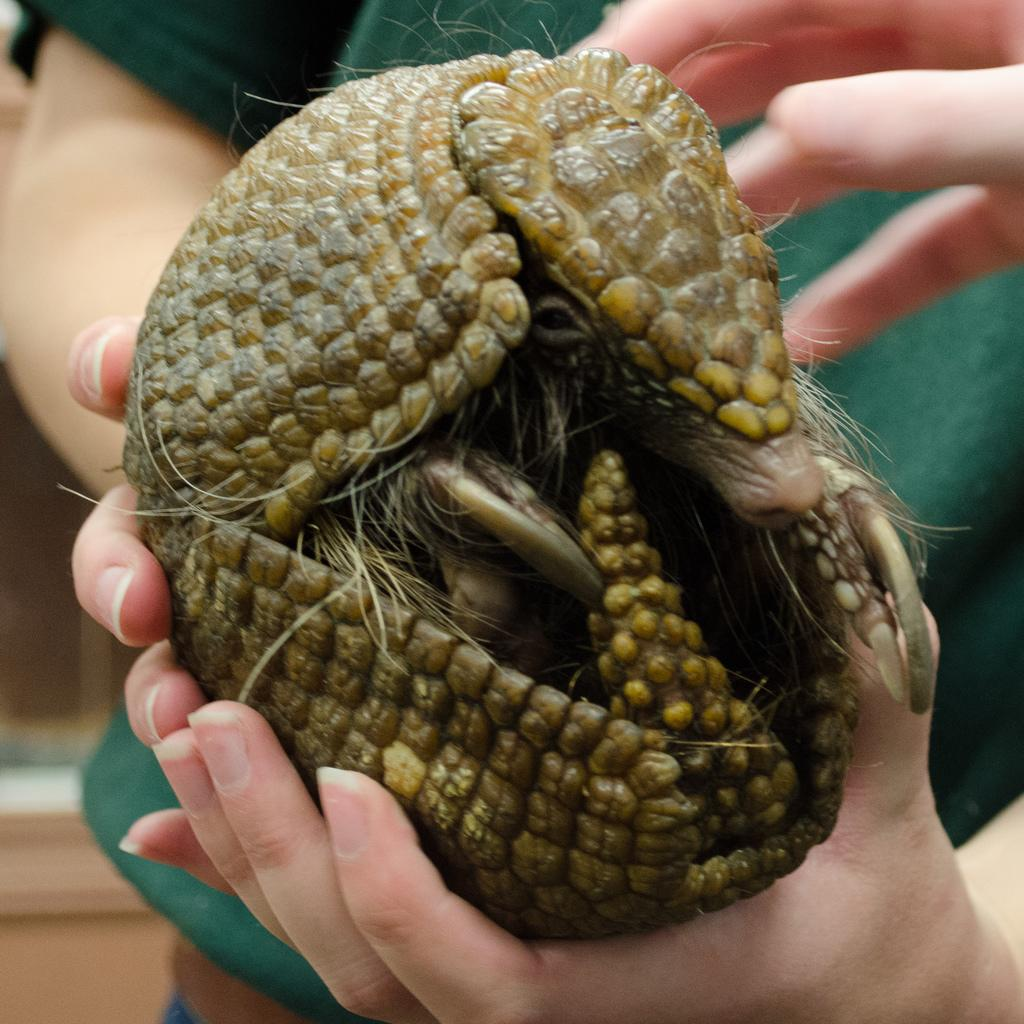What is happening in the image involving people and an animal? There are people holding an animal in the image. Can you describe the appearance of the animal? The animal has green, yellow, and black colors. What type of guide is the animal providing in the image? There is no indication in the image that the animal is providing any type of guidance. 